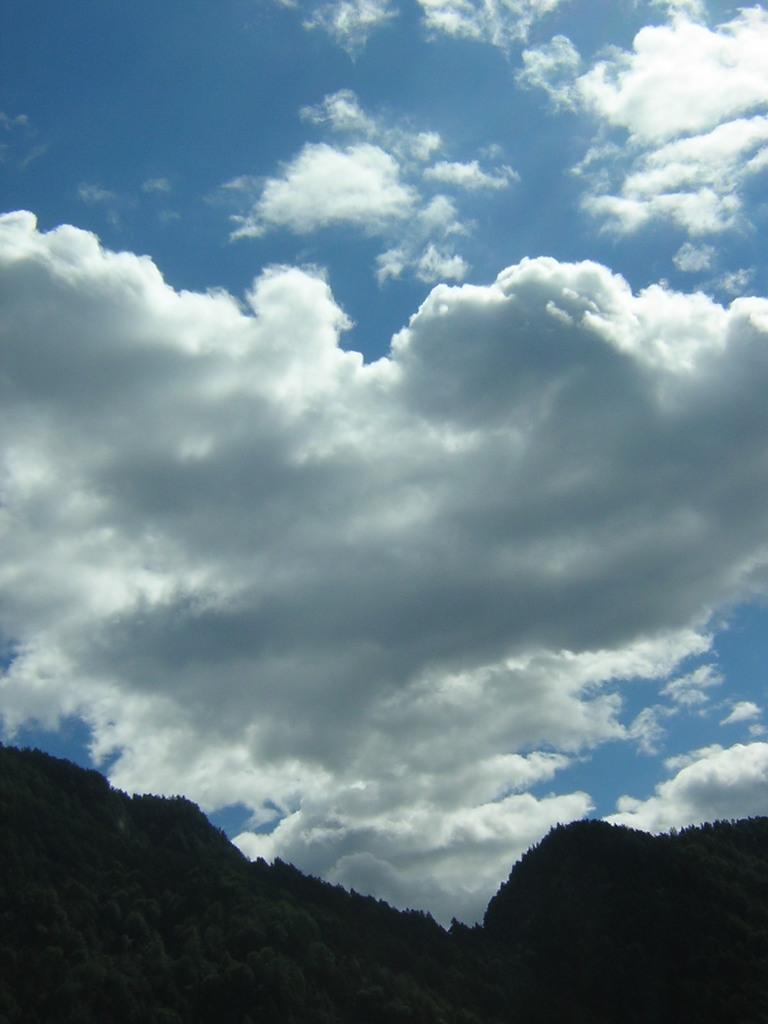Can you describe this image briefly? In this image we can see sky with clouds and hills. 